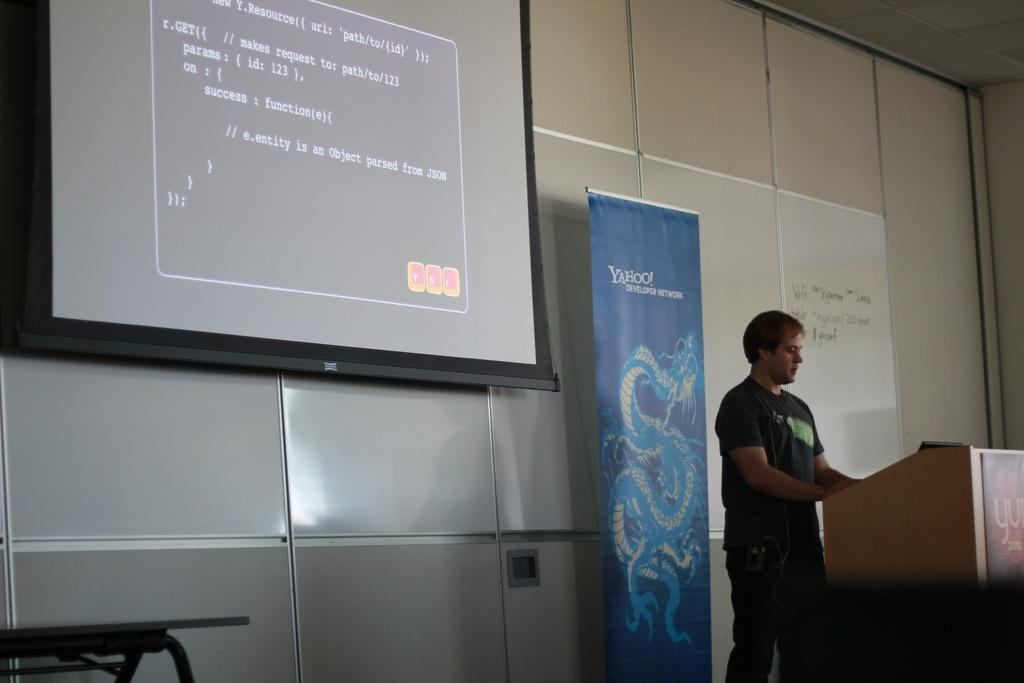What is the person in the image doing? The person is standing on a dais in the image. What is present behind the person? There is a banner and a screen behind the person. What type of list can be seen on the screen behind the person? There is no list visible on the screen in the image. 